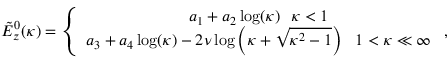Convert formula to latex. <formula><loc_0><loc_0><loc_500><loc_500>\begin{array} { r } { \tilde { E } _ { z } ^ { 0 } ( \kappa ) = \left \{ \begin{array} { c } { a _ { 1 } + a _ { 2 } \log ( \kappa ) \kappa < 1 } \\ { a _ { 3 } + a _ { 4 } \log ( \kappa ) - 2 \nu \log \left ( \kappa + \sqrt { \kappa ^ { 2 } - 1 } \right ) 1 < \kappa \ll \infty } \end{array} , } \end{array}</formula> 